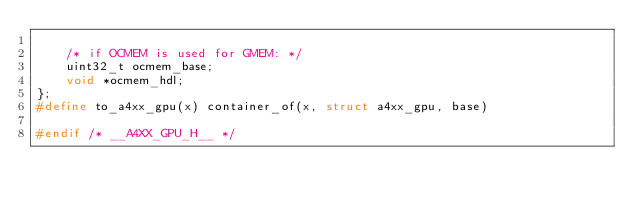<code> <loc_0><loc_0><loc_500><loc_500><_C_>
	/* if OCMEM is used for GMEM: */
	uint32_t ocmem_base;
	void *ocmem_hdl;
};
#define to_a4xx_gpu(x) container_of(x, struct a4xx_gpu, base)

#endif /* __A4XX_GPU_H__ */
</code> 